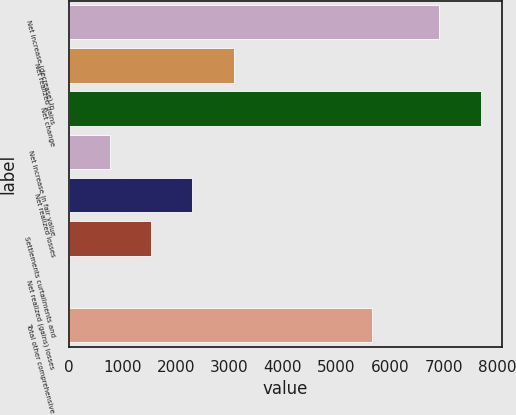<chart> <loc_0><loc_0><loc_500><loc_500><bar_chart><fcel>Net increase (decrease) in<fcel>Net realized gains<fcel>Net change<fcel>Net increase in fair value<fcel>Net realized losses<fcel>Settlements curtailments and<fcel>Net realized (gains) losses<fcel>Total other comprehensive<nl><fcel>6912<fcel>3083<fcel>7700<fcel>774.5<fcel>2313.5<fcel>1544<fcel>5<fcel>5660<nl></chart> 